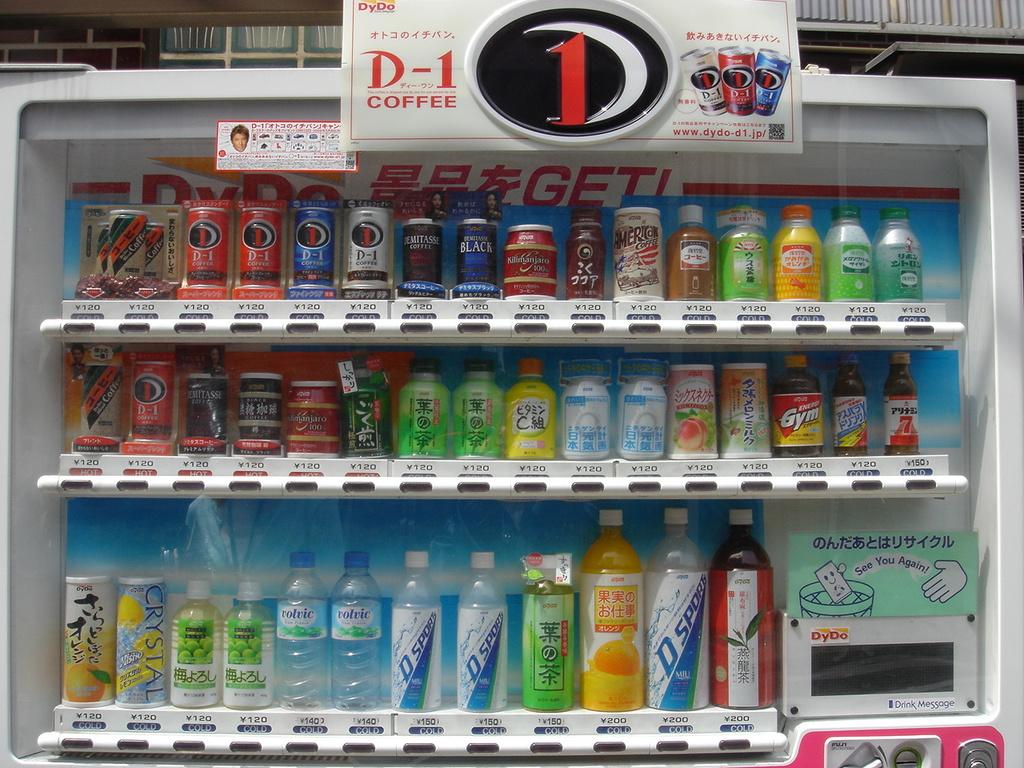What product is written under the world d1?
Offer a very short reply. Coffee. 